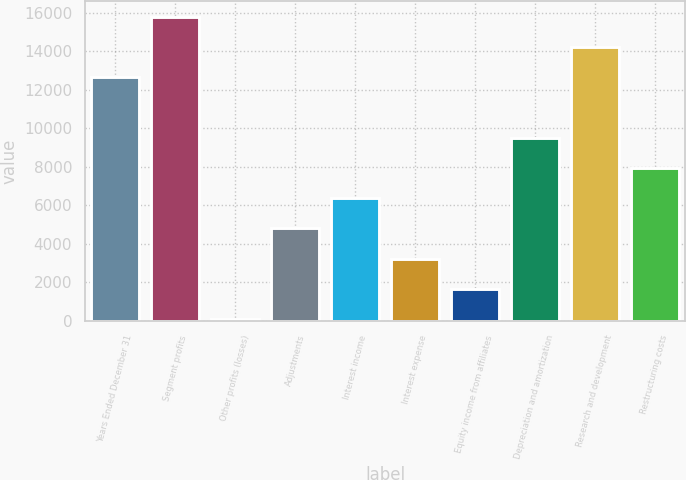Convert chart. <chart><loc_0><loc_0><loc_500><loc_500><bar_chart><fcel>Years Ended December 31<fcel>Segment profits<fcel>Other profits (losses)<fcel>Adjustments<fcel>Interest income<fcel>Interest expense<fcel>Equity income from affiliates<fcel>Depreciation and amortization<fcel>Research and development<fcel>Restructuring costs<nl><fcel>12659.2<fcel>15801<fcel>92<fcel>4804.7<fcel>6375.6<fcel>3233.8<fcel>1662.9<fcel>9517.4<fcel>14230.1<fcel>7946.5<nl></chart> 